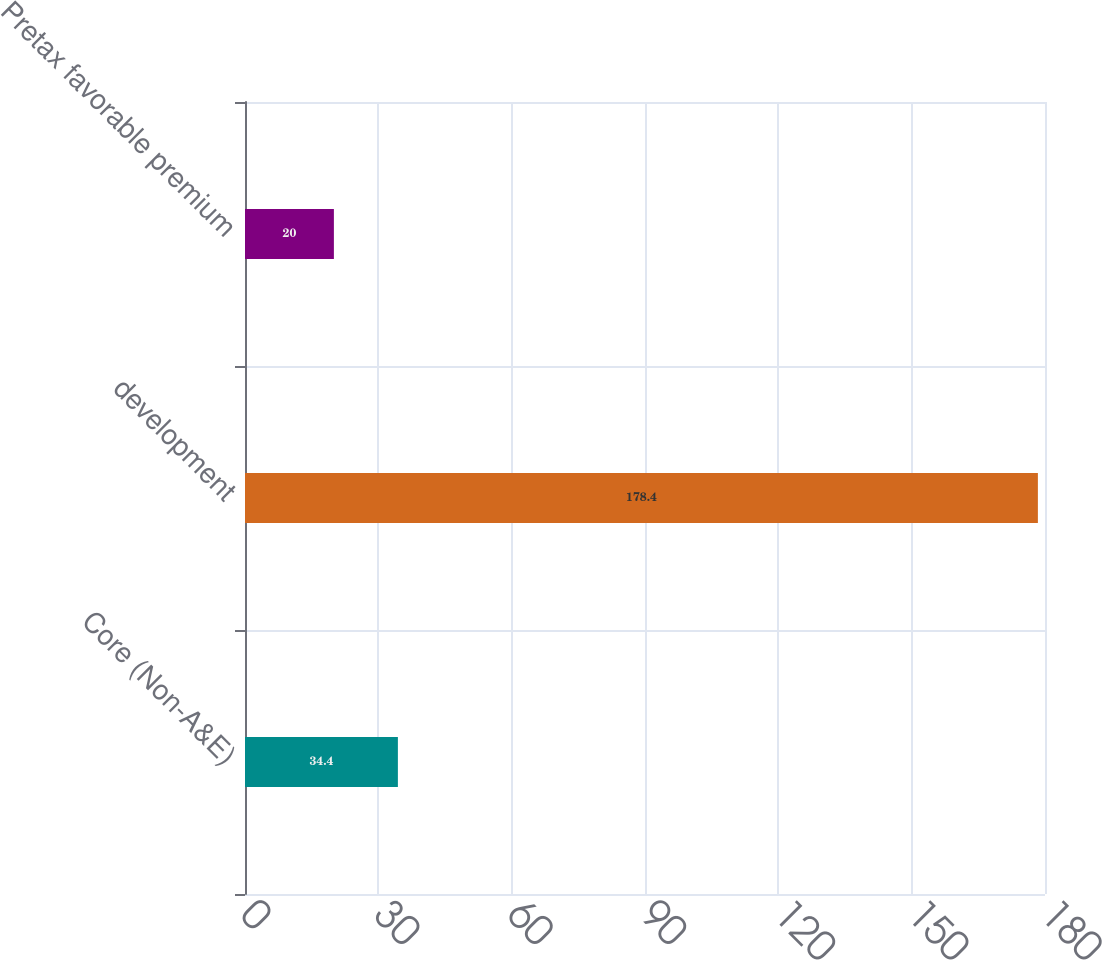Convert chart. <chart><loc_0><loc_0><loc_500><loc_500><bar_chart><fcel>Core (Non-A&E)<fcel>development<fcel>Pretax favorable premium<nl><fcel>34.4<fcel>178.4<fcel>20<nl></chart> 